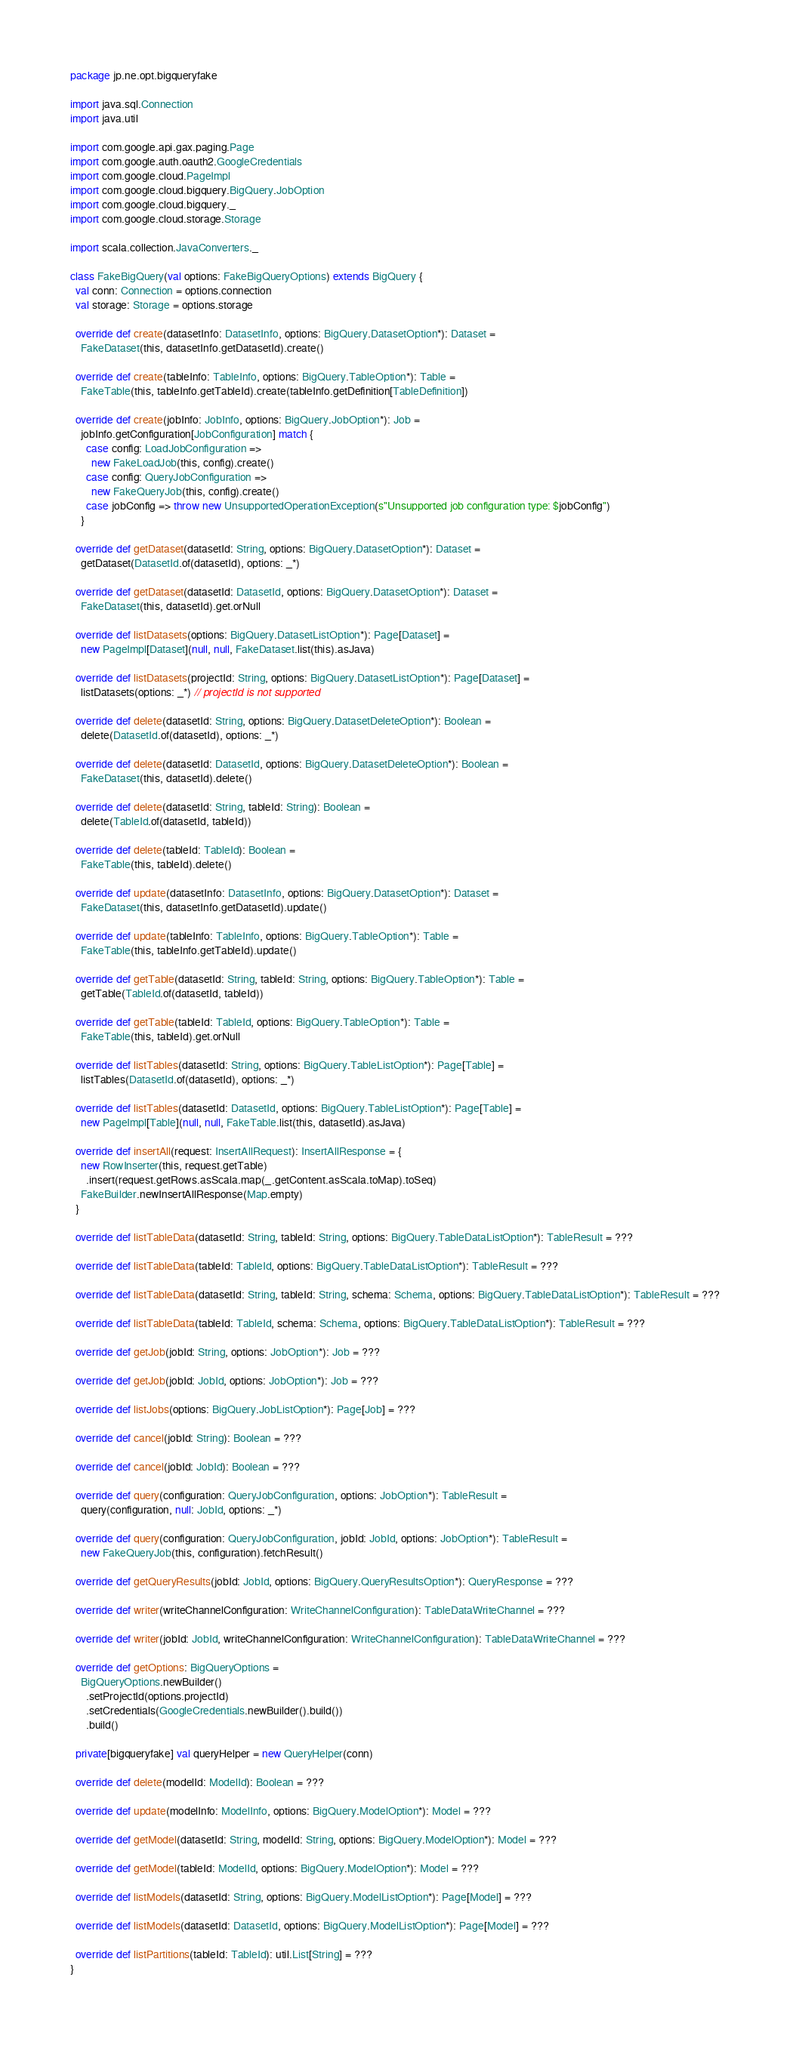<code> <loc_0><loc_0><loc_500><loc_500><_Scala_>package jp.ne.opt.bigqueryfake

import java.sql.Connection
import java.util

import com.google.api.gax.paging.Page
import com.google.auth.oauth2.GoogleCredentials
import com.google.cloud.PageImpl
import com.google.cloud.bigquery.BigQuery.JobOption
import com.google.cloud.bigquery._
import com.google.cloud.storage.Storage

import scala.collection.JavaConverters._

class FakeBigQuery(val options: FakeBigQueryOptions) extends BigQuery {
  val conn: Connection = options.connection
  val storage: Storage = options.storage

  override def create(datasetInfo: DatasetInfo, options: BigQuery.DatasetOption*): Dataset =
    FakeDataset(this, datasetInfo.getDatasetId).create()

  override def create(tableInfo: TableInfo, options: BigQuery.TableOption*): Table =
    FakeTable(this, tableInfo.getTableId).create(tableInfo.getDefinition[TableDefinition])

  override def create(jobInfo: JobInfo, options: BigQuery.JobOption*): Job =
    jobInfo.getConfiguration[JobConfiguration] match {
      case config: LoadJobConfiguration =>
        new FakeLoadJob(this, config).create()
      case config: QueryJobConfiguration =>
        new FakeQueryJob(this, config).create()
      case jobConfig => throw new UnsupportedOperationException(s"Unsupported job configuration type: $jobConfig")
    }

  override def getDataset(datasetId: String, options: BigQuery.DatasetOption*): Dataset =
    getDataset(DatasetId.of(datasetId), options: _*)

  override def getDataset(datasetId: DatasetId, options: BigQuery.DatasetOption*): Dataset =
    FakeDataset(this, datasetId).get.orNull

  override def listDatasets(options: BigQuery.DatasetListOption*): Page[Dataset] =
    new PageImpl[Dataset](null, null, FakeDataset.list(this).asJava)

  override def listDatasets(projectId: String, options: BigQuery.DatasetListOption*): Page[Dataset] =
    listDatasets(options: _*) // projectId is not supported

  override def delete(datasetId: String, options: BigQuery.DatasetDeleteOption*): Boolean =
    delete(DatasetId.of(datasetId), options: _*)

  override def delete(datasetId: DatasetId, options: BigQuery.DatasetDeleteOption*): Boolean =
    FakeDataset(this, datasetId).delete()

  override def delete(datasetId: String, tableId: String): Boolean =
    delete(TableId.of(datasetId, tableId))

  override def delete(tableId: TableId): Boolean =
    FakeTable(this, tableId).delete()

  override def update(datasetInfo: DatasetInfo, options: BigQuery.DatasetOption*): Dataset =
    FakeDataset(this, datasetInfo.getDatasetId).update()

  override def update(tableInfo: TableInfo, options: BigQuery.TableOption*): Table =
    FakeTable(this, tableInfo.getTableId).update()

  override def getTable(datasetId: String, tableId: String, options: BigQuery.TableOption*): Table =
    getTable(TableId.of(datasetId, tableId))

  override def getTable(tableId: TableId, options: BigQuery.TableOption*): Table =
    FakeTable(this, tableId).get.orNull

  override def listTables(datasetId: String, options: BigQuery.TableListOption*): Page[Table] =
    listTables(DatasetId.of(datasetId), options: _*)

  override def listTables(datasetId: DatasetId, options: BigQuery.TableListOption*): Page[Table] =
    new PageImpl[Table](null, null, FakeTable.list(this, datasetId).asJava)

  override def insertAll(request: InsertAllRequest): InsertAllResponse = {
    new RowInserter(this, request.getTable)
      .insert(request.getRows.asScala.map(_.getContent.asScala.toMap).toSeq)
    FakeBuilder.newInsertAllResponse(Map.empty)
  }

  override def listTableData(datasetId: String, tableId: String, options: BigQuery.TableDataListOption*): TableResult = ???

  override def listTableData(tableId: TableId, options: BigQuery.TableDataListOption*): TableResult = ???

  override def listTableData(datasetId: String, tableId: String, schema: Schema, options: BigQuery.TableDataListOption*): TableResult = ???

  override def listTableData(tableId: TableId, schema: Schema, options: BigQuery.TableDataListOption*): TableResult = ???

  override def getJob(jobId: String, options: JobOption*): Job = ???

  override def getJob(jobId: JobId, options: JobOption*): Job = ???

  override def listJobs(options: BigQuery.JobListOption*): Page[Job] = ???

  override def cancel(jobId: String): Boolean = ???

  override def cancel(jobId: JobId): Boolean = ???

  override def query(configuration: QueryJobConfiguration, options: JobOption*): TableResult =
    query(configuration, null: JobId, options: _*)

  override def query(configuration: QueryJobConfiguration, jobId: JobId, options: JobOption*): TableResult =
    new FakeQueryJob(this, configuration).fetchResult()

  override def getQueryResults(jobId: JobId, options: BigQuery.QueryResultsOption*): QueryResponse = ???

  override def writer(writeChannelConfiguration: WriteChannelConfiguration): TableDataWriteChannel = ???

  override def writer(jobId: JobId, writeChannelConfiguration: WriteChannelConfiguration): TableDataWriteChannel = ???

  override def getOptions: BigQueryOptions =
    BigQueryOptions.newBuilder()
      .setProjectId(options.projectId)
      .setCredentials(GoogleCredentials.newBuilder().build())
      .build()

  private[bigqueryfake] val queryHelper = new QueryHelper(conn)

  override def delete(modelId: ModelId): Boolean = ???

  override def update(modelInfo: ModelInfo, options: BigQuery.ModelOption*): Model = ???

  override def getModel(datasetId: String, modelId: String, options: BigQuery.ModelOption*): Model = ???

  override def getModel(tableId: ModelId, options: BigQuery.ModelOption*): Model = ???

  override def listModels(datasetId: String, options: BigQuery.ModelListOption*): Page[Model] = ???

  override def listModels(datasetId: DatasetId, options: BigQuery.ModelListOption*): Page[Model] = ???

  override def listPartitions(tableId: TableId): util.List[String] = ???
}
</code> 